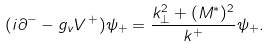<formula> <loc_0><loc_0><loc_500><loc_500>( i \partial ^ { - } - g _ { v } { V } ^ { \, + } ) \psi _ { + } = \frac { k _ { \bot } ^ { 2 } + ( M ^ { * } ) ^ { 2 } } { k ^ { + } } \psi _ { + } .</formula> 